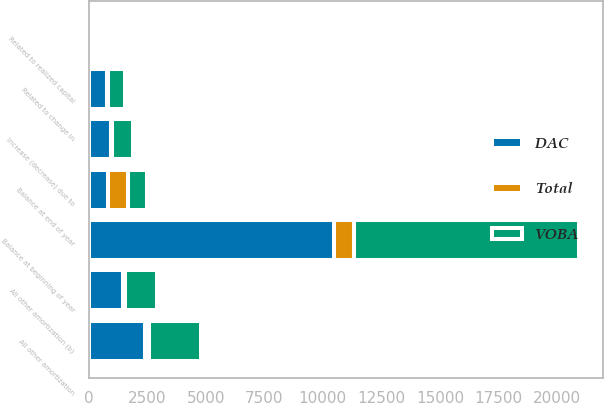Convert chart to OTSL. <chart><loc_0><loc_0><loc_500><loc_500><stacked_bar_chart><ecel><fcel>Balance at beginning of year<fcel>Related to realized capital<fcel>All other amortization (b)<fcel>Related to change in<fcel>Balance at end of year<fcel>All other amortization<fcel>Increase (decrease) due to<nl><fcel>VOBA<fcel>9599<fcel>77<fcel>1387<fcel>744<fcel>833<fcel>2214<fcel>904<nl><fcel>Total<fcel>869<fcel>16<fcel>81<fcel>34<fcel>833<fcel>185<fcel>44<nl><fcel>DAC<fcel>10468<fcel>93<fcel>1468<fcel>778<fcel>833<fcel>2399<fcel>948<nl></chart> 